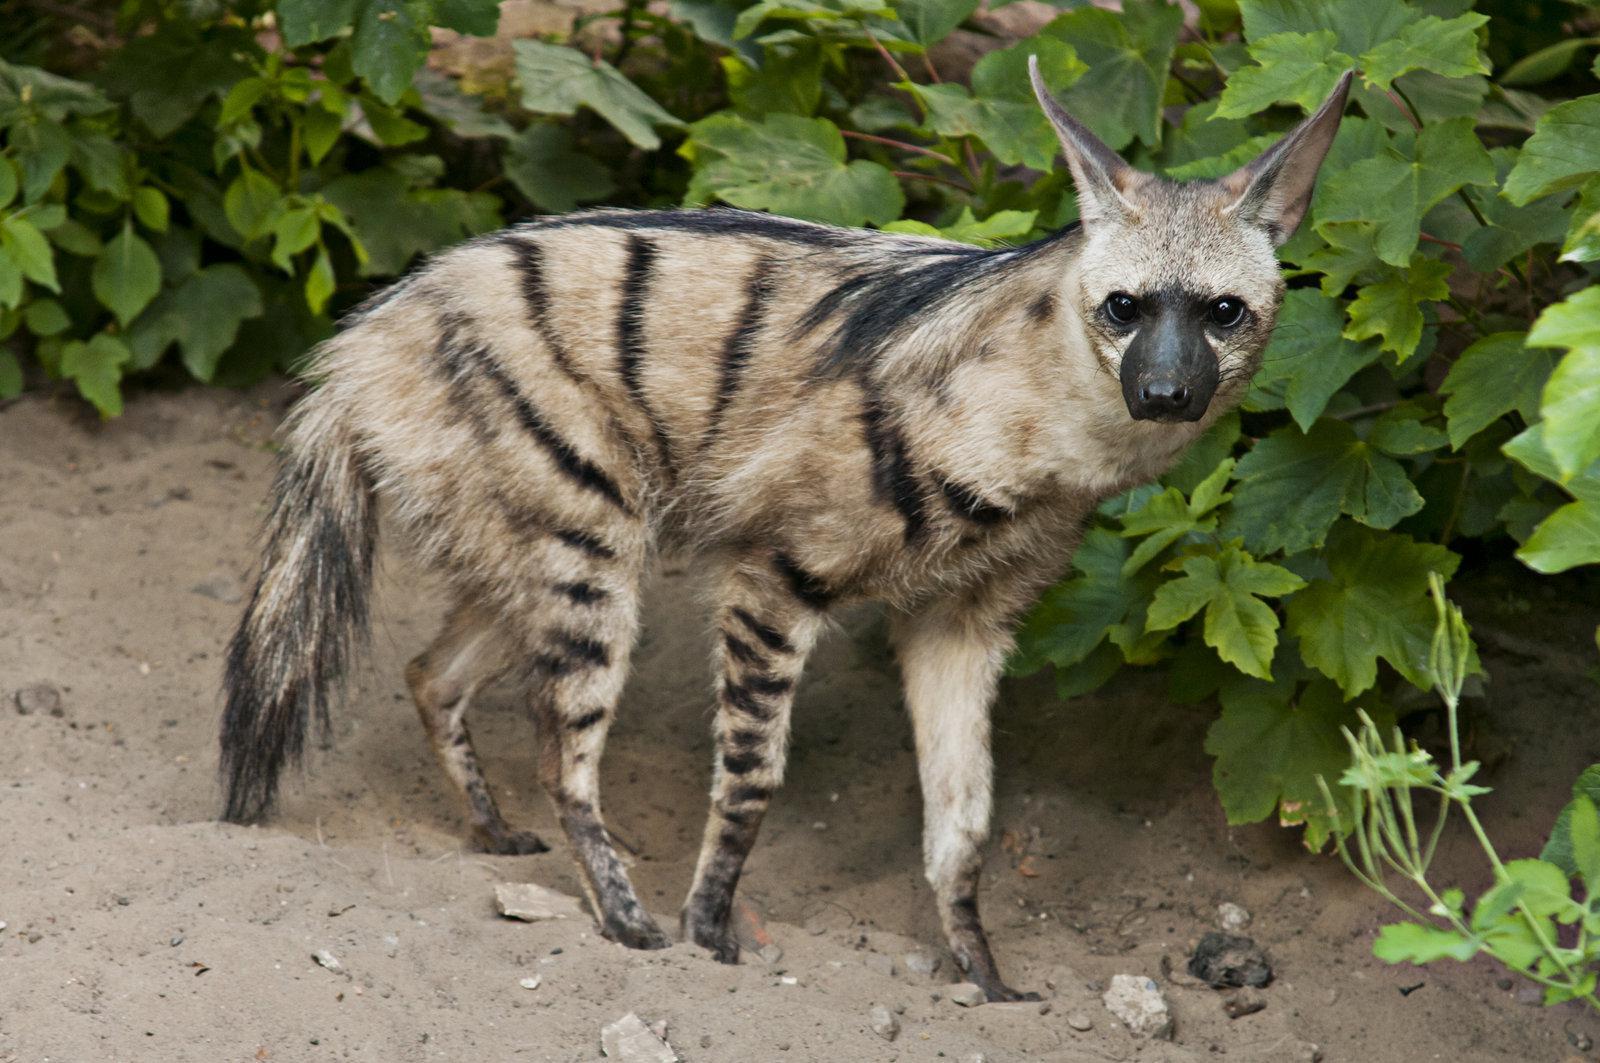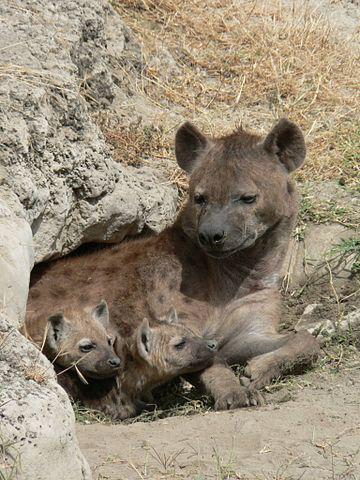The first image is the image on the left, the second image is the image on the right. For the images displayed, is the sentence "A single animal stands in one of the images, while an animal lies on the ground in the other." factually correct? Answer yes or no. Yes. The first image is the image on the left, the second image is the image on the right. Examine the images to the left and right. Is the description "The combined images contain a total of four hyenas, including at least one hyena pup posed with its parent." accurate? Answer yes or no. Yes. 